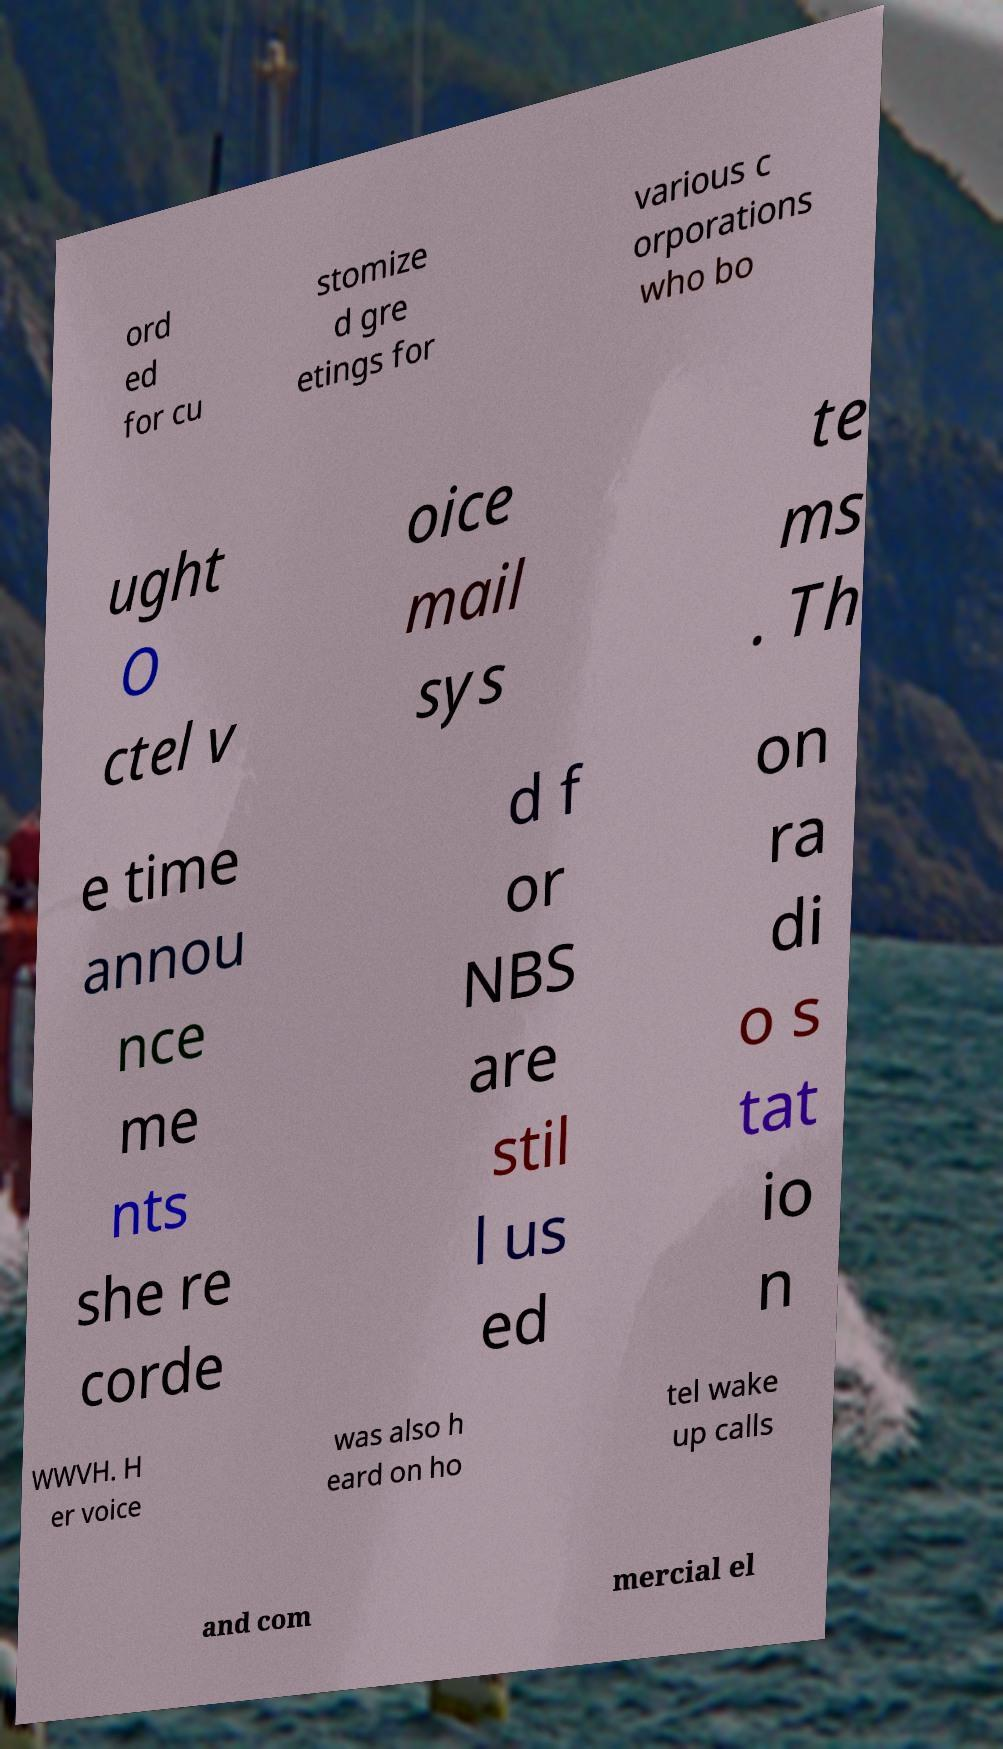For documentation purposes, I need the text within this image transcribed. Could you provide that? ord ed for cu stomize d gre etings for various c orporations who bo ught O ctel v oice mail sys te ms . Th e time annou nce me nts she re corde d f or NBS are stil l us ed on ra di o s tat io n WWVH. H er voice was also h eard on ho tel wake up calls and com mercial el 